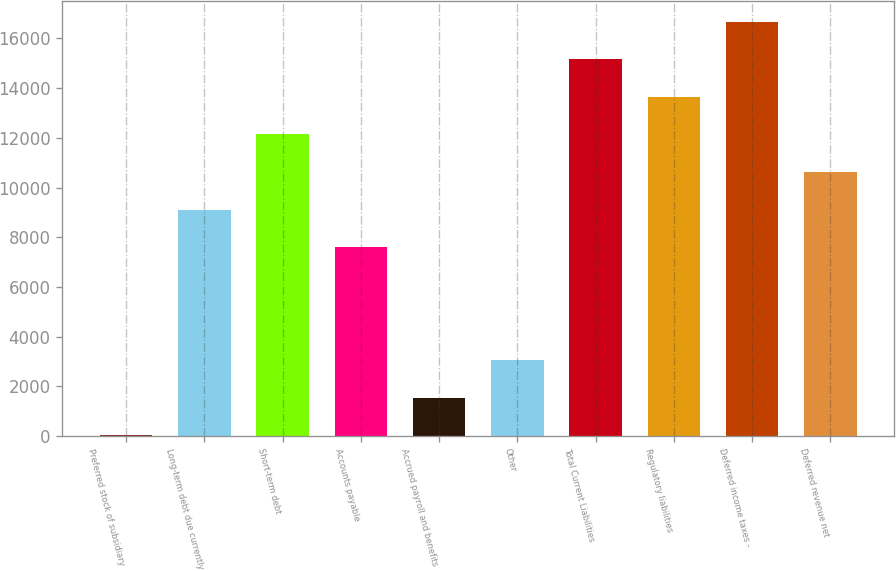Convert chart to OTSL. <chart><loc_0><loc_0><loc_500><loc_500><bar_chart><fcel>Preferred stock of subsidiary<fcel>Long-term debt due currently<fcel>Short-term debt<fcel>Accounts payable<fcel>Accrued payroll and benefits<fcel>Other<fcel>Total Current Liabilities<fcel>Regulatory liabilities<fcel>Deferred income taxes -<fcel>Deferred revenue net<nl><fcel>30.4<fcel>9110.2<fcel>12136.8<fcel>7596.9<fcel>1543.7<fcel>3057<fcel>15163.4<fcel>13650.1<fcel>16676.7<fcel>10623.5<nl></chart> 